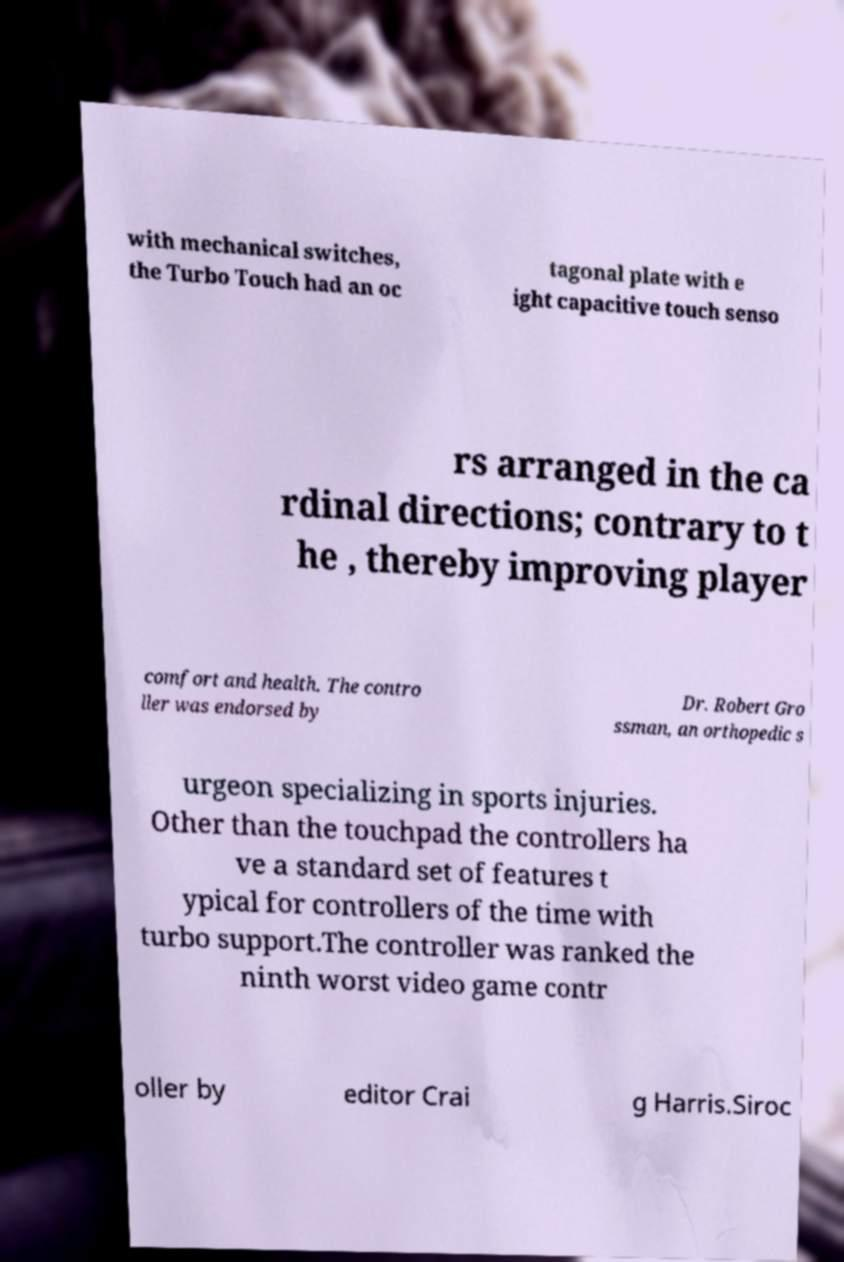Could you extract and type out the text from this image? with mechanical switches, the Turbo Touch had an oc tagonal plate with e ight capacitive touch senso rs arranged in the ca rdinal directions; contrary to t he , thereby improving player comfort and health. The contro ller was endorsed by Dr. Robert Gro ssman, an orthopedic s urgeon specializing in sports injuries. Other than the touchpad the controllers ha ve a standard set of features t ypical for controllers of the time with turbo support.The controller was ranked the ninth worst video game contr oller by editor Crai g Harris.Siroc 